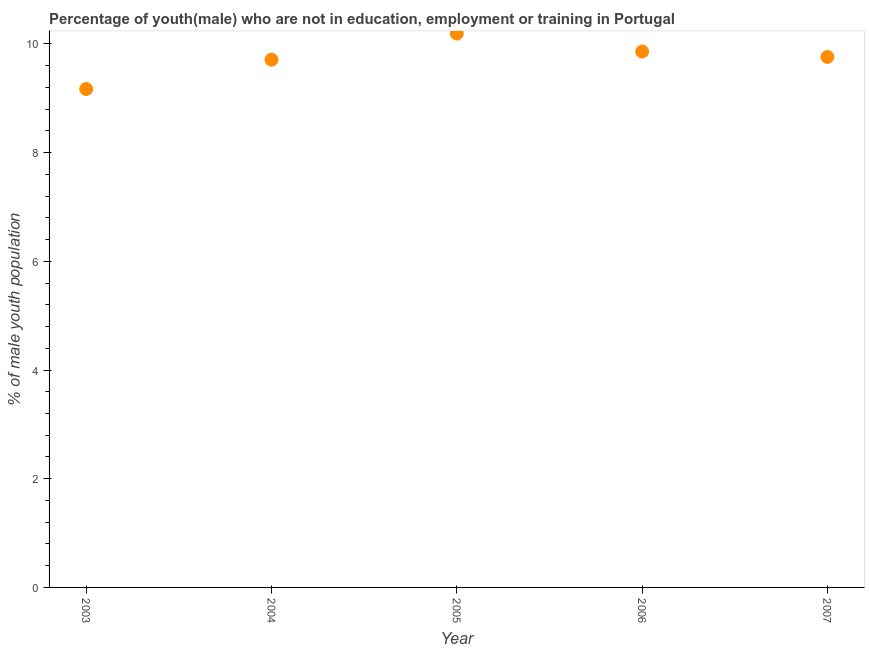What is the unemployed male youth population in 2007?
Keep it short and to the point. 9.76. Across all years, what is the maximum unemployed male youth population?
Give a very brief answer. 10.19. Across all years, what is the minimum unemployed male youth population?
Give a very brief answer. 9.17. In which year was the unemployed male youth population maximum?
Offer a terse response. 2005. What is the sum of the unemployed male youth population?
Offer a terse response. 48.69. What is the difference between the unemployed male youth population in 2006 and 2007?
Keep it short and to the point. 0.1. What is the average unemployed male youth population per year?
Provide a short and direct response. 9.74. What is the median unemployed male youth population?
Make the answer very short. 9.76. Do a majority of the years between 2005 and 2004 (inclusive) have unemployed male youth population greater than 9.6 %?
Your response must be concise. No. What is the ratio of the unemployed male youth population in 2004 to that in 2006?
Give a very brief answer. 0.98. Is the difference between the unemployed male youth population in 2004 and 2006 greater than the difference between any two years?
Your response must be concise. No. What is the difference between the highest and the second highest unemployed male youth population?
Offer a very short reply. 0.33. Is the sum of the unemployed male youth population in 2004 and 2007 greater than the maximum unemployed male youth population across all years?
Provide a short and direct response. Yes. What is the difference between the highest and the lowest unemployed male youth population?
Offer a terse response. 1.02. In how many years, is the unemployed male youth population greater than the average unemployed male youth population taken over all years?
Your answer should be compact. 3. How many years are there in the graph?
Keep it short and to the point. 5. Does the graph contain any zero values?
Your answer should be compact. No. Does the graph contain grids?
Provide a short and direct response. No. What is the title of the graph?
Give a very brief answer. Percentage of youth(male) who are not in education, employment or training in Portugal. What is the label or title of the X-axis?
Give a very brief answer. Year. What is the label or title of the Y-axis?
Provide a short and direct response. % of male youth population. What is the % of male youth population in 2003?
Ensure brevity in your answer.  9.17. What is the % of male youth population in 2004?
Provide a succinct answer. 9.71. What is the % of male youth population in 2005?
Give a very brief answer. 10.19. What is the % of male youth population in 2006?
Your response must be concise. 9.86. What is the % of male youth population in 2007?
Your response must be concise. 9.76. What is the difference between the % of male youth population in 2003 and 2004?
Your answer should be very brief. -0.54. What is the difference between the % of male youth population in 2003 and 2005?
Provide a succinct answer. -1.02. What is the difference between the % of male youth population in 2003 and 2006?
Ensure brevity in your answer.  -0.69. What is the difference between the % of male youth population in 2003 and 2007?
Your response must be concise. -0.59. What is the difference between the % of male youth population in 2004 and 2005?
Give a very brief answer. -0.48. What is the difference between the % of male youth population in 2005 and 2006?
Offer a terse response. 0.33. What is the difference between the % of male youth population in 2005 and 2007?
Provide a short and direct response. 0.43. What is the difference between the % of male youth population in 2006 and 2007?
Make the answer very short. 0.1. What is the ratio of the % of male youth population in 2003 to that in 2004?
Provide a short and direct response. 0.94. What is the ratio of the % of male youth population in 2003 to that in 2007?
Your answer should be very brief. 0.94. What is the ratio of the % of male youth population in 2004 to that in 2005?
Offer a very short reply. 0.95. What is the ratio of the % of male youth population in 2004 to that in 2007?
Provide a succinct answer. 0.99. What is the ratio of the % of male youth population in 2005 to that in 2006?
Your response must be concise. 1.03. What is the ratio of the % of male youth population in 2005 to that in 2007?
Offer a very short reply. 1.04. What is the ratio of the % of male youth population in 2006 to that in 2007?
Offer a very short reply. 1.01. 